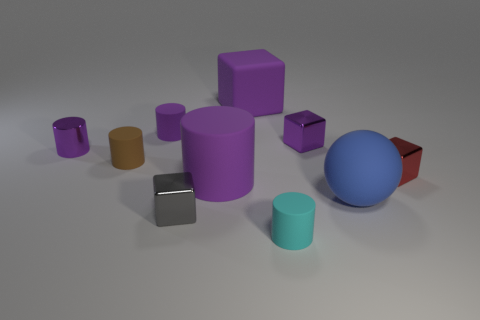There is a tiny rubber object in front of the red metallic thing; is it the same color as the large cube?
Your response must be concise. No. What number of small gray shiny things are to the left of the rubber cylinder that is behind the purple cube that is to the right of the big purple cube?
Your answer should be very brief. 0. There is a tiny purple block; how many matte things are right of it?
Offer a very short reply. 1. There is a small metal object that is the same shape as the cyan matte object; what color is it?
Your response must be concise. Purple. There is a tiny cylinder that is to the right of the brown cylinder and behind the large purple matte cylinder; what is its material?
Your answer should be very brief. Rubber. There is a gray metal cube to the right of the brown rubber cylinder; is its size the same as the red metallic block?
Make the answer very short. Yes. What material is the small gray object?
Provide a succinct answer. Metal. There is a matte cylinder that is behind the brown thing; what is its color?
Your answer should be compact. Purple. How many big things are gray objects or brown cylinders?
Ensure brevity in your answer.  0. There is a big block that is to the left of the tiny cyan cylinder; is it the same color as the big object on the left side of the large block?
Provide a succinct answer. Yes. 